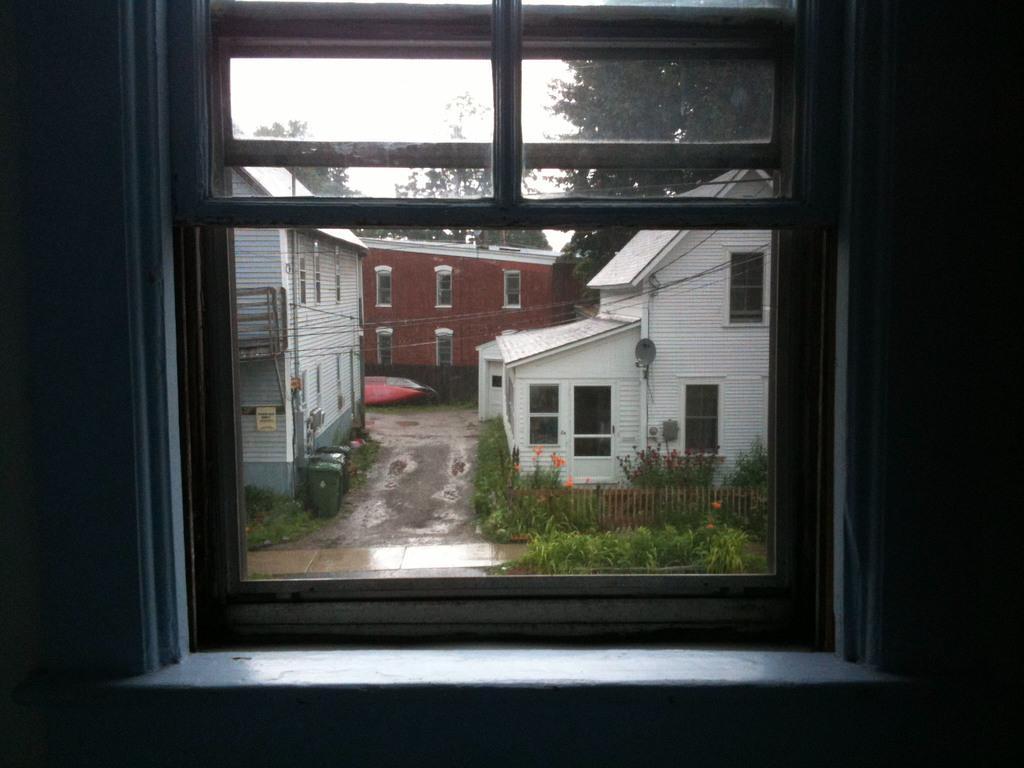How would you summarize this image in a sentence or two? In this image there is a window and we can see sheds, trees, bins and a fence through the window glass. 